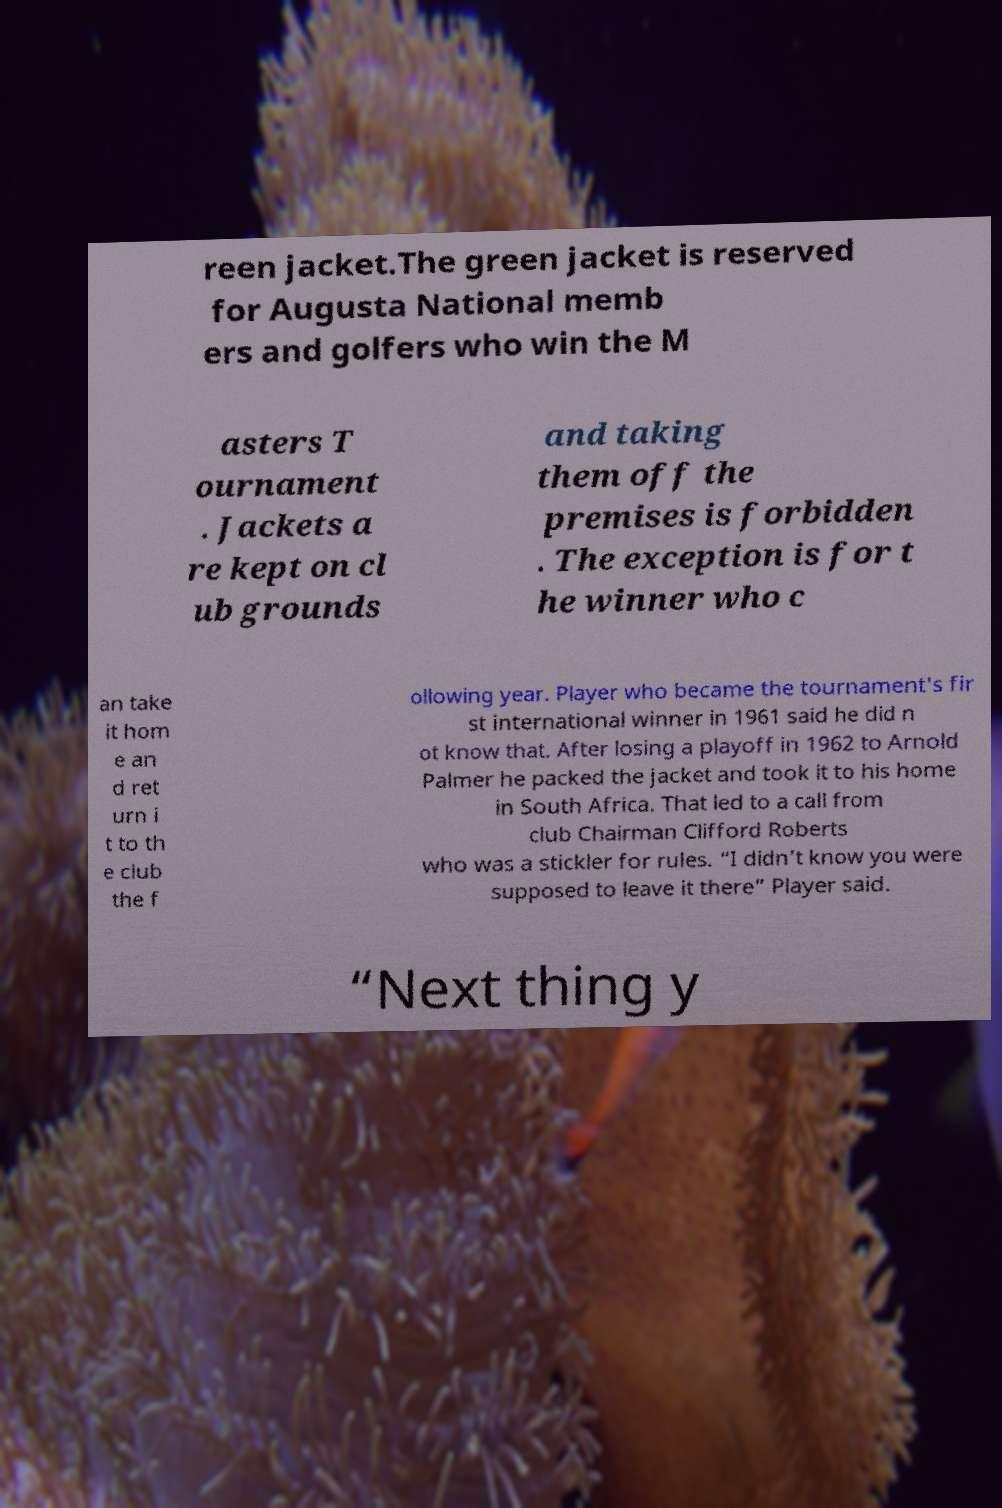Please read and relay the text visible in this image. What does it say? reen jacket.The green jacket is reserved for Augusta National memb ers and golfers who win the M asters T ournament . Jackets a re kept on cl ub grounds and taking them off the premises is forbidden . The exception is for t he winner who c an take it hom e an d ret urn i t to th e club the f ollowing year. Player who became the tournament's fir st international winner in 1961 said he did n ot know that. After losing a playoff in 1962 to Arnold Palmer he packed the jacket and took it to his home in South Africa. That led to a call from club Chairman Clifford Roberts who was a stickler for rules. “I didn’t know you were supposed to leave it there” Player said. “Next thing y 